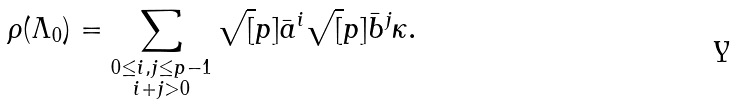<formula> <loc_0><loc_0><loc_500><loc_500>\rho ( \Lambda _ { 0 } ) = \sum _ { \substack { 0 \leq i , j \leq p - 1 \\ i + j > 0 } } \sqrt { [ } p ] { \bar { a } } ^ { i } \sqrt { [ } p ] { \bar { b } } ^ { j } \kappa .</formula> 